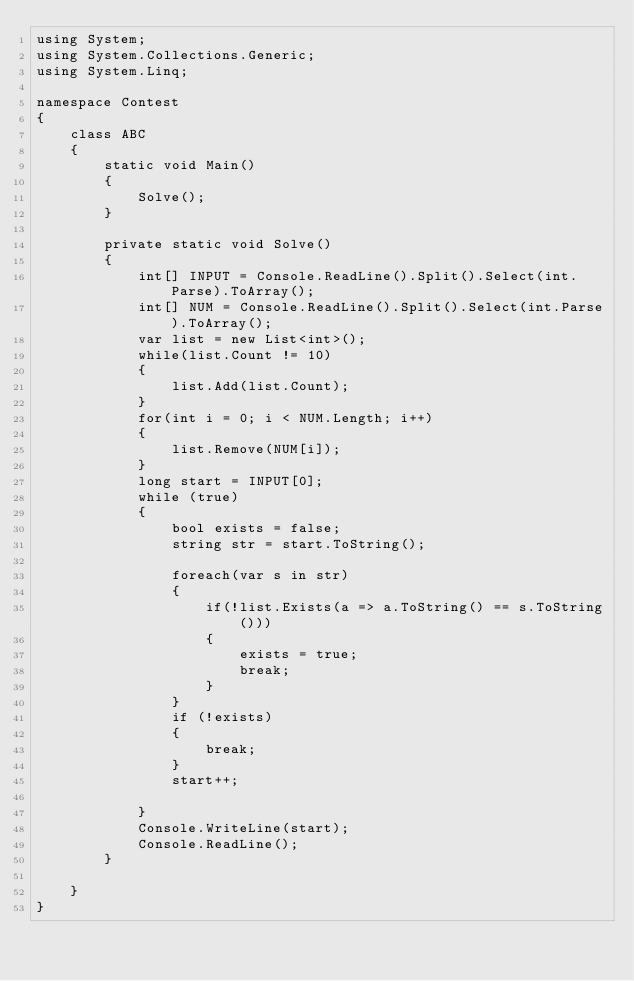Convert code to text. <code><loc_0><loc_0><loc_500><loc_500><_C#_>using System;
using System.Collections.Generic;
using System.Linq;

namespace Contest
{
    class ABC
    {
        static void Main()
        {
            Solve();
        }

        private static void Solve()
        {
            int[] INPUT = Console.ReadLine().Split().Select(int.Parse).ToArray();
            int[] NUM = Console.ReadLine().Split().Select(int.Parse).ToArray();
            var list = new List<int>();
            while(list.Count != 10)
            {
                list.Add(list.Count);
            }
            for(int i = 0; i < NUM.Length; i++)
            {
                list.Remove(NUM[i]);
            }
            long start = INPUT[0];
            while (true)
            {
                bool exists = false;
                string str = start.ToString();

                foreach(var s in str)
                {
                    if(!list.Exists(a => a.ToString() == s.ToString()))
                    {
                        exists = true;
                        break;
                    }
                }
                if (!exists)
                {
                    break;
                }
                start++;

            }
            Console.WriteLine(start);
            Console.ReadLine();
        }

    }
}
</code> 